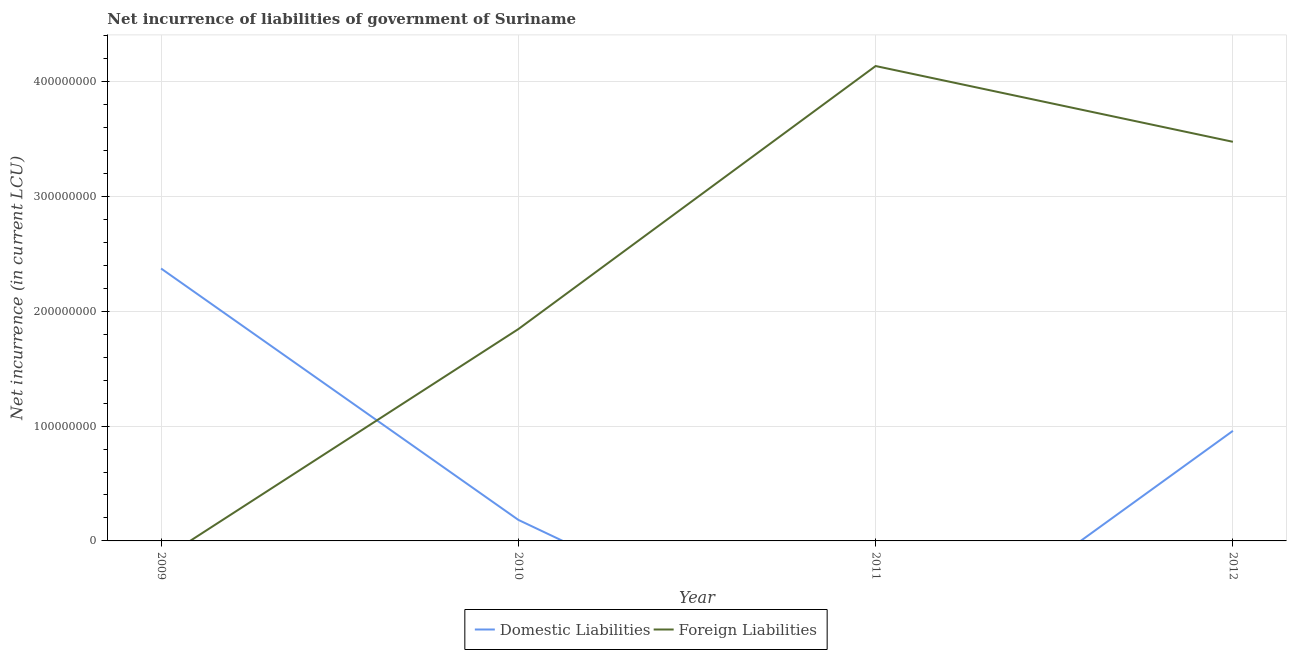How many different coloured lines are there?
Provide a succinct answer. 2. Is the number of lines equal to the number of legend labels?
Your answer should be compact. No. What is the net incurrence of foreign liabilities in 2010?
Make the answer very short. 1.84e+08. Across all years, what is the maximum net incurrence of foreign liabilities?
Provide a succinct answer. 4.14e+08. In which year was the net incurrence of domestic liabilities maximum?
Give a very brief answer. 2009. What is the total net incurrence of domestic liabilities in the graph?
Make the answer very short. 3.51e+08. What is the difference between the net incurrence of domestic liabilities in 2009 and that in 2012?
Provide a short and direct response. 1.41e+08. What is the difference between the net incurrence of foreign liabilities in 2009 and the net incurrence of domestic liabilities in 2010?
Give a very brief answer. -1.83e+07. What is the average net incurrence of domestic liabilities per year?
Offer a very short reply. 8.79e+07. In the year 2010, what is the difference between the net incurrence of domestic liabilities and net incurrence of foreign liabilities?
Your answer should be very brief. -1.66e+08. What is the ratio of the net incurrence of domestic liabilities in 2009 to that in 2012?
Keep it short and to the point. 2.47. What is the difference between the highest and the second highest net incurrence of foreign liabilities?
Offer a terse response. 6.60e+07. What is the difference between the highest and the lowest net incurrence of foreign liabilities?
Provide a succinct answer. 4.14e+08. Is the sum of the net incurrence of foreign liabilities in 2010 and 2012 greater than the maximum net incurrence of domestic liabilities across all years?
Keep it short and to the point. Yes. Does the net incurrence of foreign liabilities monotonically increase over the years?
Offer a very short reply. No. Is the net incurrence of foreign liabilities strictly less than the net incurrence of domestic liabilities over the years?
Make the answer very short. No. How many years are there in the graph?
Offer a very short reply. 4. What is the difference between two consecutive major ticks on the Y-axis?
Provide a short and direct response. 1.00e+08. Does the graph contain grids?
Provide a succinct answer. Yes. Where does the legend appear in the graph?
Your answer should be compact. Bottom center. How many legend labels are there?
Your response must be concise. 2. What is the title of the graph?
Provide a succinct answer. Net incurrence of liabilities of government of Suriname. What is the label or title of the Y-axis?
Your response must be concise. Net incurrence (in current LCU). What is the Net incurrence (in current LCU) in Domestic Liabilities in 2009?
Keep it short and to the point. 2.37e+08. What is the Net incurrence (in current LCU) in Foreign Liabilities in 2009?
Make the answer very short. 0. What is the Net incurrence (in current LCU) in Domestic Liabilities in 2010?
Your response must be concise. 1.83e+07. What is the Net incurrence (in current LCU) of Foreign Liabilities in 2010?
Give a very brief answer. 1.84e+08. What is the Net incurrence (in current LCU) in Foreign Liabilities in 2011?
Your response must be concise. 4.14e+08. What is the Net incurrence (in current LCU) of Domestic Liabilities in 2012?
Offer a terse response. 9.59e+07. What is the Net incurrence (in current LCU) in Foreign Liabilities in 2012?
Keep it short and to the point. 3.48e+08. Across all years, what is the maximum Net incurrence (in current LCU) in Domestic Liabilities?
Provide a succinct answer. 2.37e+08. Across all years, what is the maximum Net incurrence (in current LCU) of Foreign Liabilities?
Offer a very short reply. 4.14e+08. Across all years, what is the minimum Net incurrence (in current LCU) in Domestic Liabilities?
Make the answer very short. 0. Across all years, what is the minimum Net incurrence (in current LCU) in Foreign Liabilities?
Offer a very short reply. 0. What is the total Net incurrence (in current LCU) in Domestic Liabilities in the graph?
Keep it short and to the point. 3.51e+08. What is the total Net incurrence (in current LCU) of Foreign Liabilities in the graph?
Your answer should be very brief. 9.46e+08. What is the difference between the Net incurrence (in current LCU) of Domestic Liabilities in 2009 and that in 2010?
Keep it short and to the point. 2.19e+08. What is the difference between the Net incurrence (in current LCU) of Domestic Liabilities in 2009 and that in 2012?
Your response must be concise. 1.41e+08. What is the difference between the Net incurrence (in current LCU) in Foreign Liabilities in 2010 and that in 2011?
Make the answer very short. -2.29e+08. What is the difference between the Net incurrence (in current LCU) of Domestic Liabilities in 2010 and that in 2012?
Keep it short and to the point. -7.76e+07. What is the difference between the Net incurrence (in current LCU) of Foreign Liabilities in 2010 and that in 2012?
Offer a very short reply. -1.63e+08. What is the difference between the Net incurrence (in current LCU) in Foreign Liabilities in 2011 and that in 2012?
Offer a terse response. 6.60e+07. What is the difference between the Net incurrence (in current LCU) of Domestic Liabilities in 2009 and the Net incurrence (in current LCU) of Foreign Liabilities in 2010?
Provide a succinct answer. 5.27e+07. What is the difference between the Net incurrence (in current LCU) of Domestic Liabilities in 2009 and the Net incurrence (in current LCU) of Foreign Liabilities in 2011?
Offer a very short reply. -1.76e+08. What is the difference between the Net incurrence (in current LCU) in Domestic Liabilities in 2009 and the Net incurrence (in current LCU) in Foreign Liabilities in 2012?
Your answer should be very brief. -1.10e+08. What is the difference between the Net incurrence (in current LCU) in Domestic Liabilities in 2010 and the Net incurrence (in current LCU) in Foreign Liabilities in 2011?
Provide a short and direct response. -3.95e+08. What is the difference between the Net incurrence (in current LCU) in Domestic Liabilities in 2010 and the Net incurrence (in current LCU) in Foreign Liabilities in 2012?
Offer a very short reply. -3.29e+08. What is the average Net incurrence (in current LCU) in Domestic Liabilities per year?
Your answer should be compact. 8.79e+07. What is the average Net incurrence (in current LCU) in Foreign Liabilities per year?
Keep it short and to the point. 2.36e+08. In the year 2010, what is the difference between the Net incurrence (in current LCU) in Domestic Liabilities and Net incurrence (in current LCU) in Foreign Liabilities?
Keep it short and to the point. -1.66e+08. In the year 2012, what is the difference between the Net incurrence (in current LCU) of Domestic Liabilities and Net incurrence (in current LCU) of Foreign Liabilities?
Give a very brief answer. -2.52e+08. What is the ratio of the Net incurrence (in current LCU) of Domestic Liabilities in 2009 to that in 2010?
Ensure brevity in your answer.  12.95. What is the ratio of the Net incurrence (in current LCU) of Domestic Liabilities in 2009 to that in 2012?
Give a very brief answer. 2.47. What is the ratio of the Net incurrence (in current LCU) of Foreign Liabilities in 2010 to that in 2011?
Keep it short and to the point. 0.45. What is the ratio of the Net incurrence (in current LCU) of Domestic Liabilities in 2010 to that in 2012?
Offer a terse response. 0.19. What is the ratio of the Net incurrence (in current LCU) of Foreign Liabilities in 2010 to that in 2012?
Keep it short and to the point. 0.53. What is the ratio of the Net incurrence (in current LCU) in Foreign Liabilities in 2011 to that in 2012?
Ensure brevity in your answer.  1.19. What is the difference between the highest and the second highest Net incurrence (in current LCU) in Domestic Liabilities?
Offer a terse response. 1.41e+08. What is the difference between the highest and the second highest Net incurrence (in current LCU) in Foreign Liabilities?
Give a very brief answer. 6.60e+07. What is the difference between the highest and the lowest Net incurrence (in current LCU) in Domestic Liabilities?
Provide a short and direct response. 2.37e+08. What is the difference between the highest and the lowest Net incurrence (in current LCU) of Foreign Liabilities?
Offer a very short reply. 4.14e+08. 